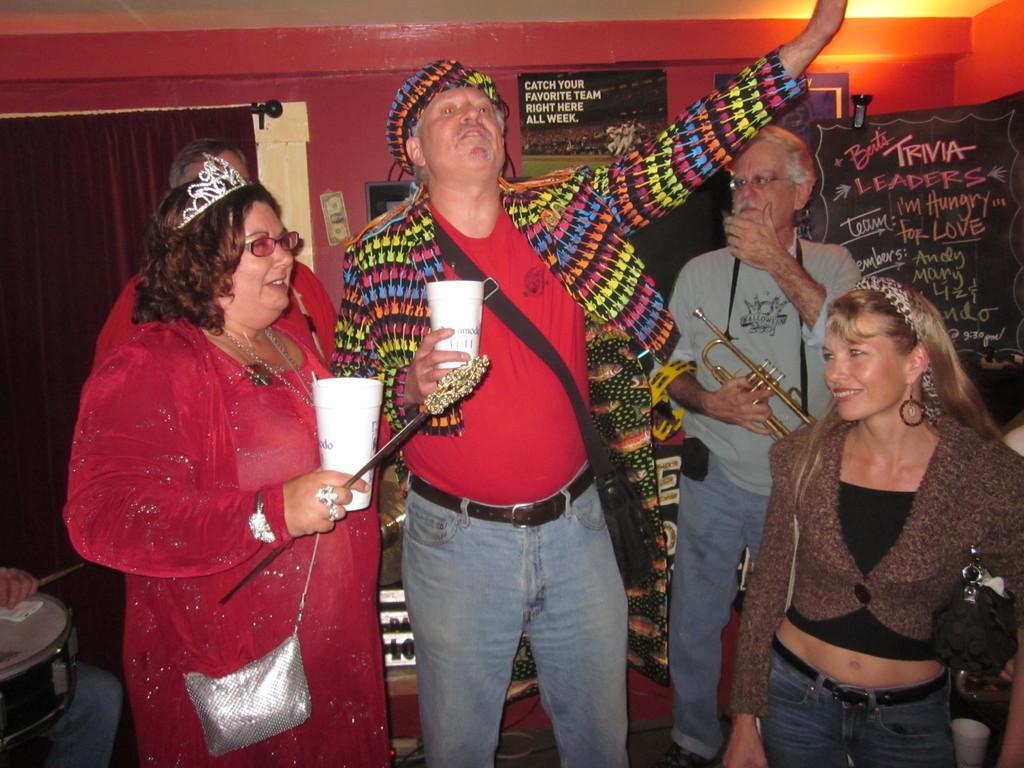Please provide a concise description of this image. In this picture I can see few people standing and couple of them holding glasses in their hands and I can see a man holding a trumpet and couple of boards with some text in the back and I can see a woman wearing a crown and a bag, I can see a drum and a human hand holding a drumstick at the bottom left corner of the picture. 